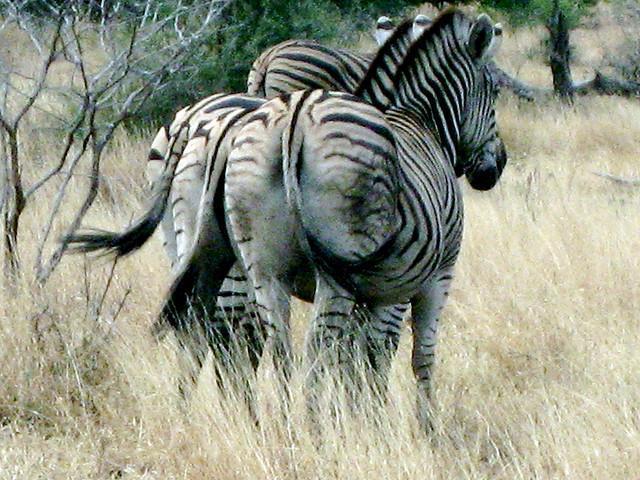How many zebras are there?
Give a very brief answer. 3. 